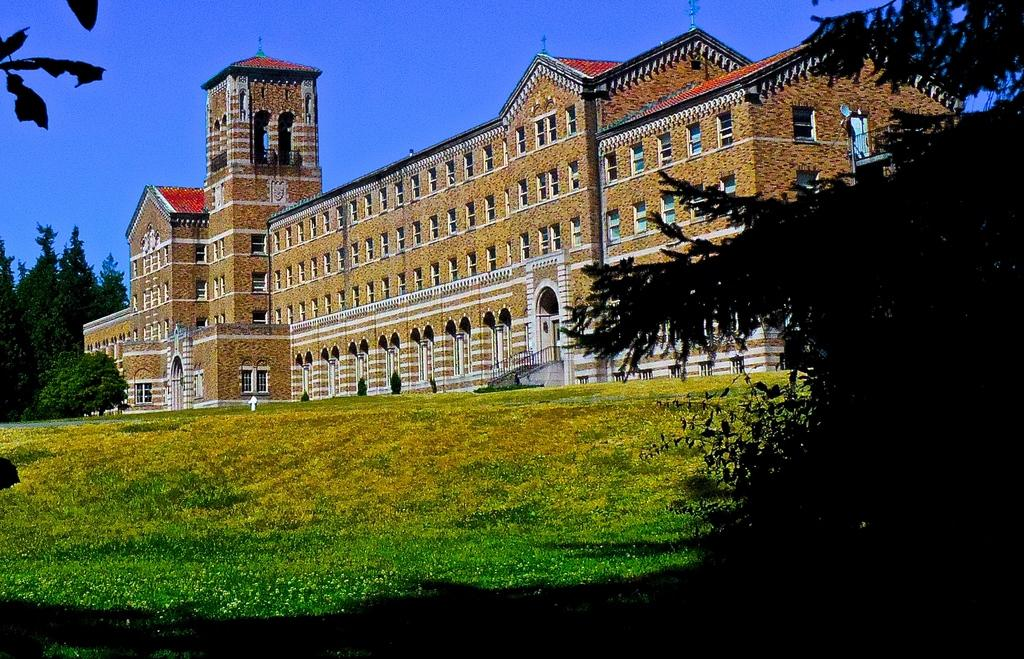What type of landscape is depicted in the image? There is a grassland in the image. What can be seen on the right side of the image? There is a tree on the right side of the image. What is visible in the background of the image? There is a building, trees, and the sky visible in the background of the image. What type of juice is being served in the image? There is no juice present in the image; it features a grassland, a tree, and a background with a building, trees, and the sky. 